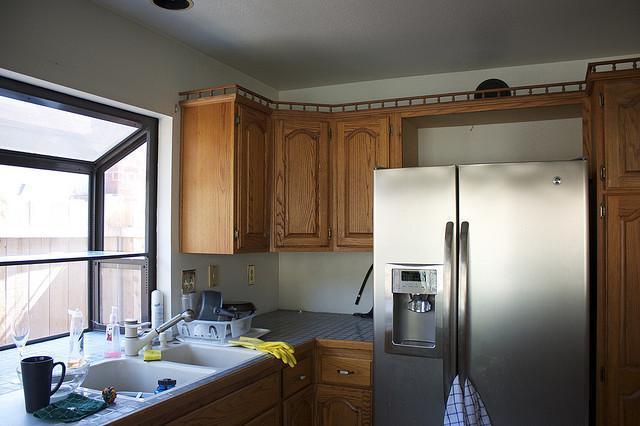How many refrigerators can be seen?
Give a very brief answer. 1. 